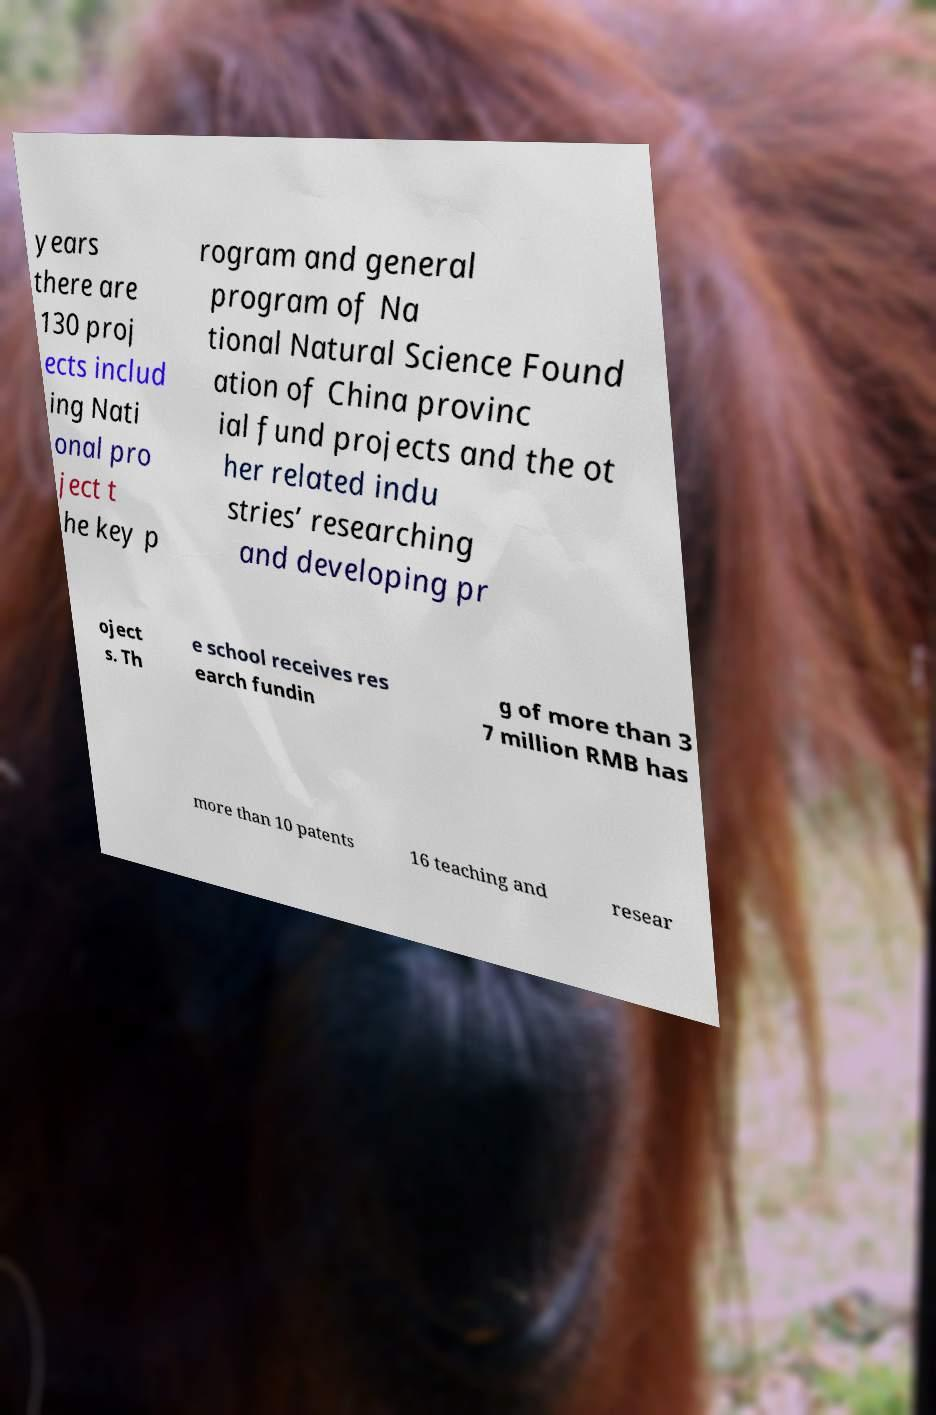There's text embedded in this image that I need extracted. Can you transcribe it verbatim? years there are 130 proj ects includ ing Nati onal pro ject t he key p rogram and general program of Na tional Natural Science Found ation of China provinc ial fund projects and the ot her related indu stries’ researching and developing pr oject s. Th e school receives res earch fundin g of more than 3 7 million RMB has more than 10 patents 16 teaching and resear 